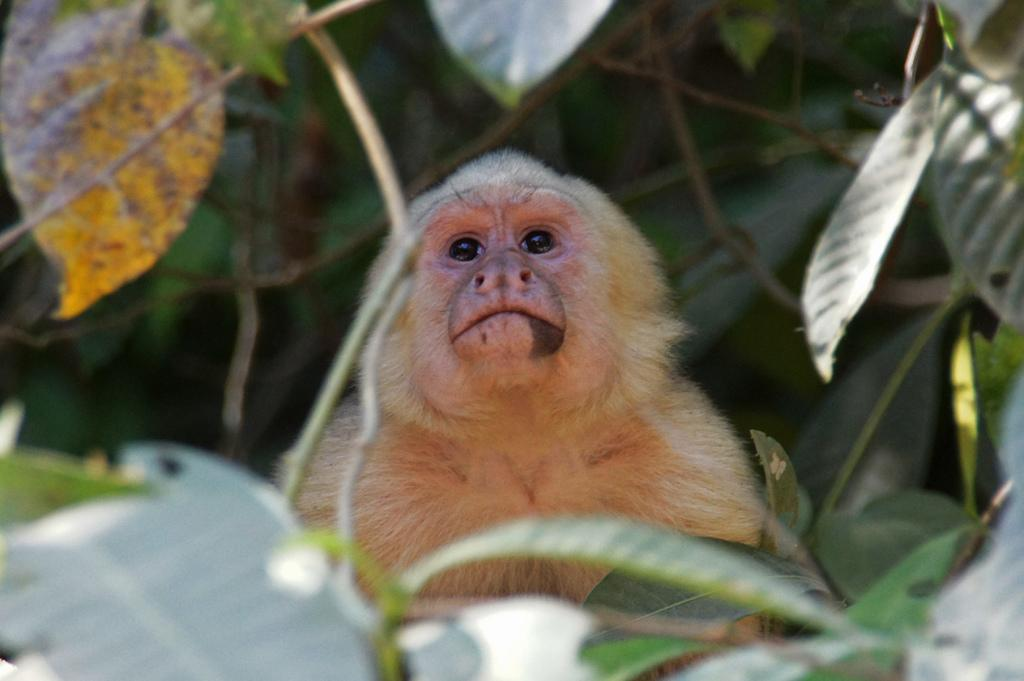What type of animal is in the image? There is a monkey in the image. What else can be seen in the image besides the monkey? There are plants in the image. What type of punishment is the monkey receiving in the image? There is: There is no indication of punishment in the image; the monkey is simply present among the plants. 